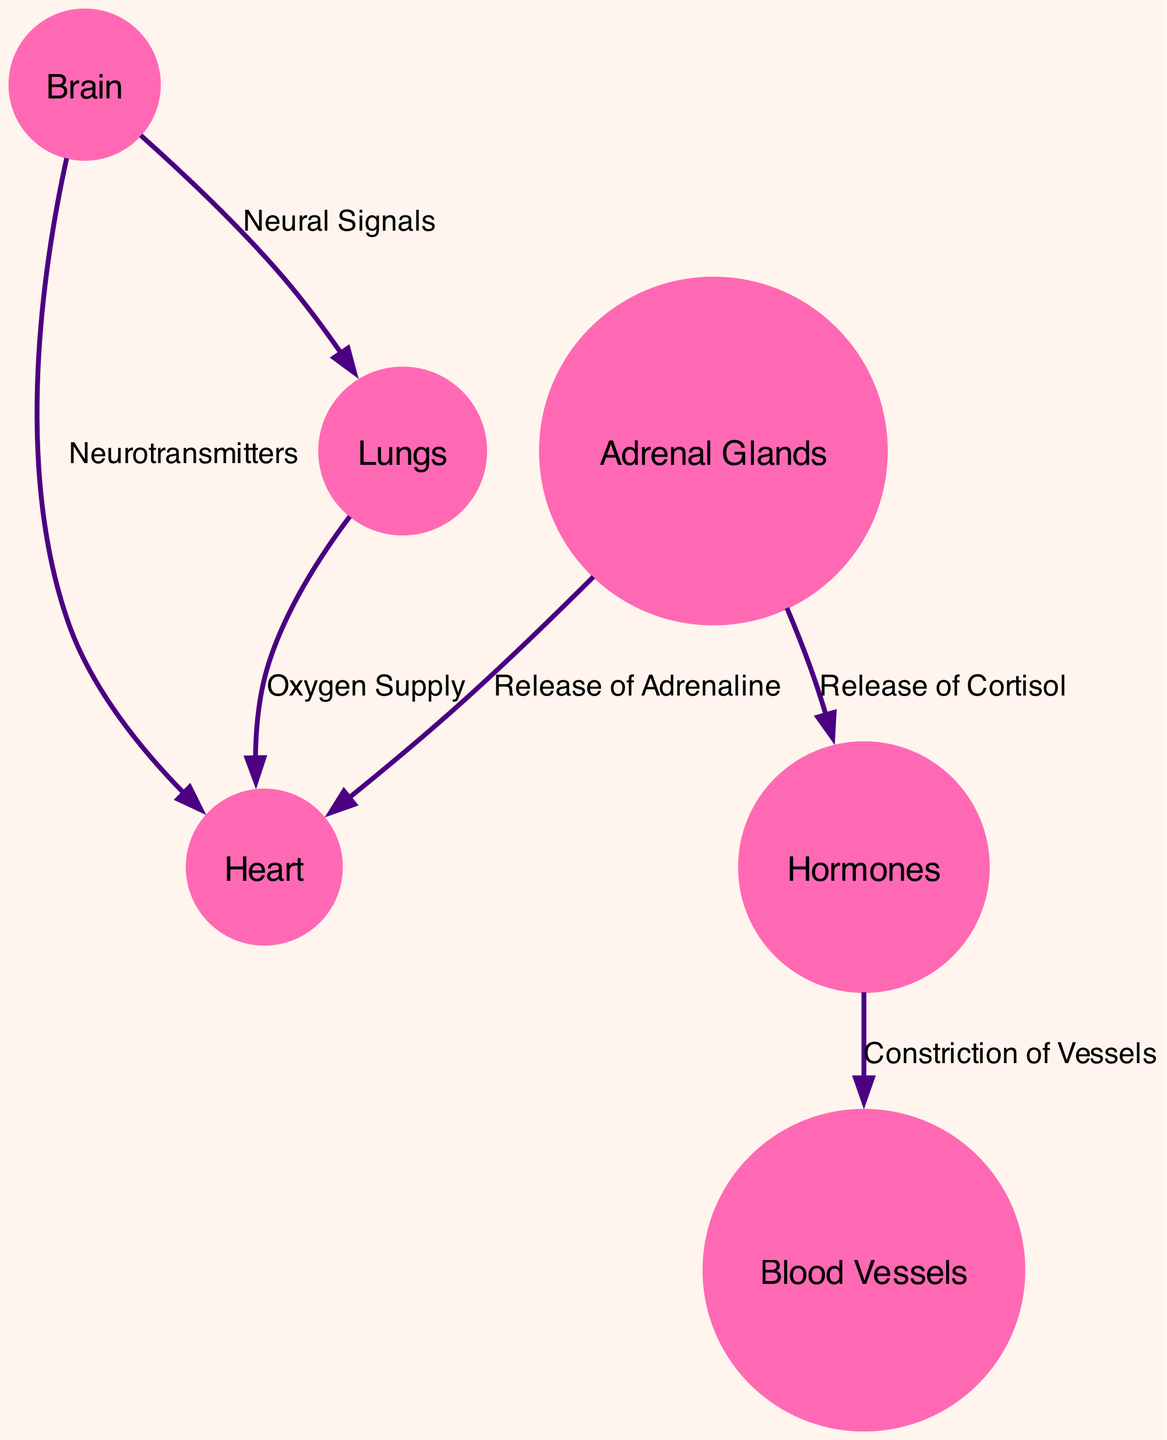What is the central organ affected during heartbreak? The diagram indicates that the heart is the central organ significantly impacted during heartbreak as it is specifically labeled and described as such.
Answer: Heart How many nodes are depicted in the diagram? To determine the number of nodes, we count each node listed under the “nodes” section of the data. There are 6 nodes total.
Answer: 6 What hormone is released by the adrenal glands that affects heart rate? The diagram shows that the adrenal glands are responsible for the release of adrenaline, which is noted to increase heart rate.
Answer: Adrenaline What process does cortisol initiate in relation to blood vessels? The connection from hormones indicates that cortisol causes the constriction of blood vessels, leading to an increase in blood pressure.
Answer: Constriction of Vessels Which organ's activity increases breathing rate in response to emotional stress? The diagram suggests that the brain coordinates the body's reaction to stress, thereby increasing the breathing rate through neural signals.
Answer: Brain How is oxygen supply related to emotional stress according to the diagram? The diagram shows that oxygen supply is elevated to meet the increased heart rate triggered by emotional stress, implying a direct connection between these elements.
Answer: Oxygen Supply What effect does the brain have on the heart? According to the diagram, the brain transmits neurotransmitters that signal stress to the heart, indicating a critical role in regulating heart function under stress.
Answer: Neurotransmitters What is the relationship between cortisol and emotional response? The diagram indicates that cortisol acts as a hormone that heightens emotional response, thereby establishing a link between cortisol release and emotional intensity during stress.
Answer: Heighten emotional response Which relationships involve the adrenal glands? There are two relationships stemming from the adrenal glands: the release of adrenaline to the heart (increasing heart rate) and the release of cortisol affecting hormonal levels.
Answer: Release of Adrenaline, Release of Cortisol 